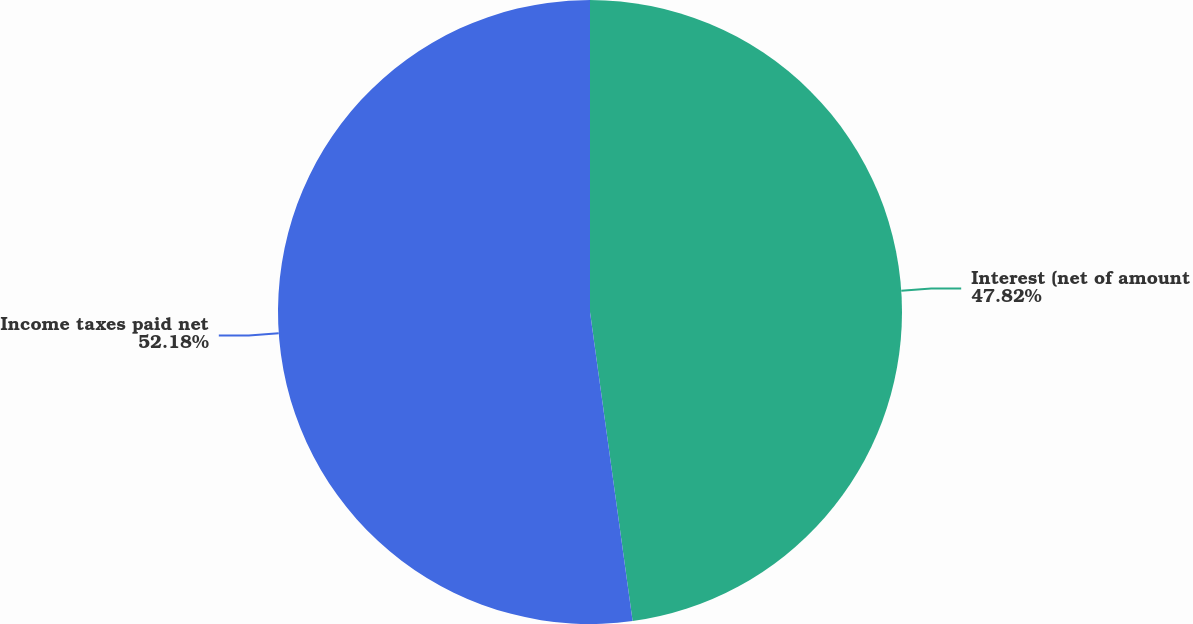Convert chart. <chart><loc_0><loc_0><loc_500><loc_500><pie_chart><fcel>Interest (net of amount<fcel>Income taxes paid net<nl><fcel>47.82%<fcel>52.18%<nl></chart> 